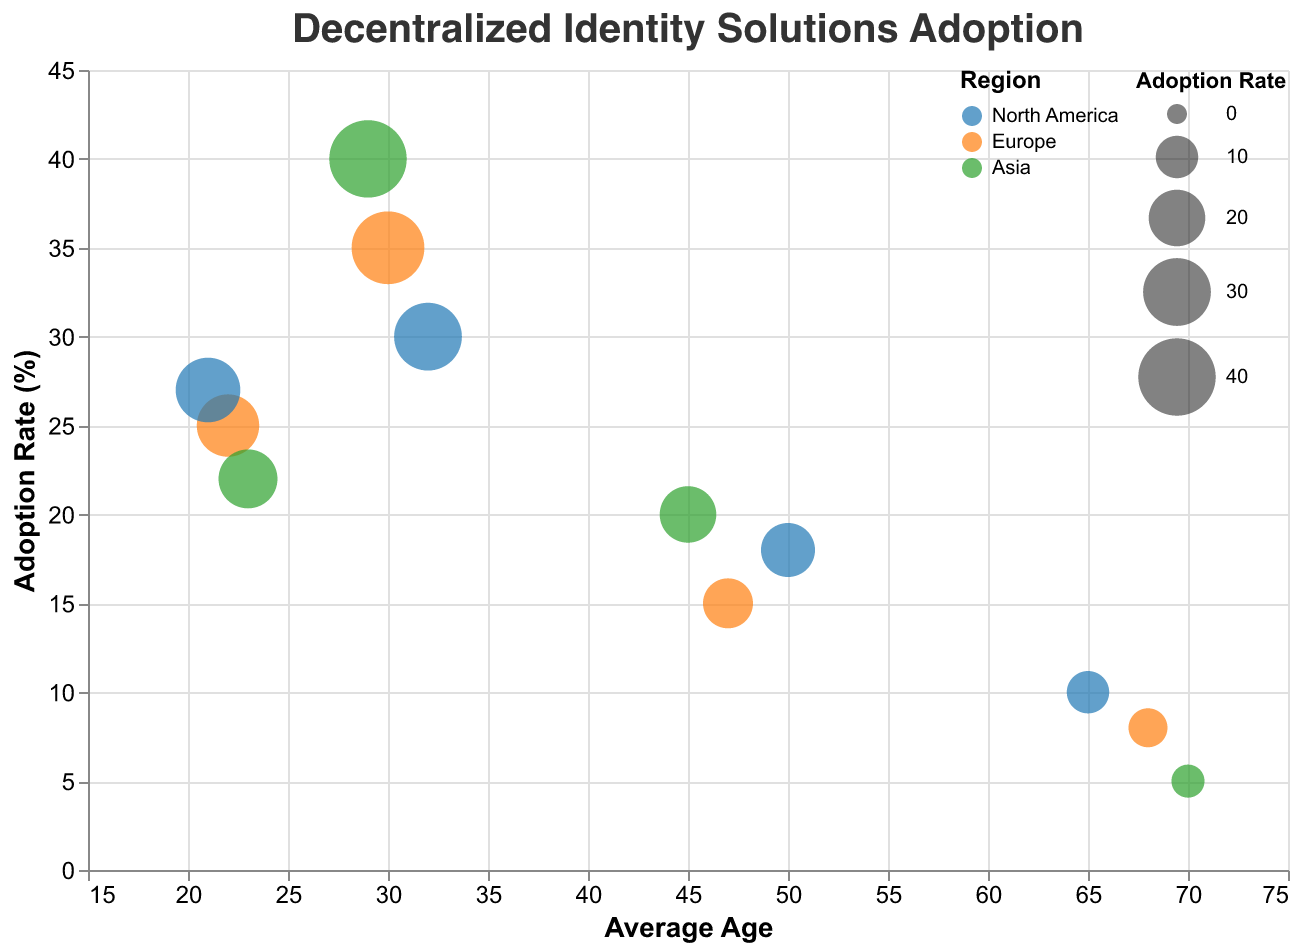What demographic group has the highest adoption rate in Asia? From the Bubble Chart, SolidChain representing Millennials in Asia has the highest adoption rate. The bubble size and position indicate an adoption rate of 40%.
Answer: Millennials What's the overall trend in adoption rate versus average age? Observing the Bubble Chart, as the average age increases, the adoption rate generally decreases. Younger groups (Millennials and Gen Z) have higher adoption rates compared to older groups (Gen X and Baby Boomers).
Answer: Decreases Which demographic group in North America has the lowest adoption rate? Looking at the Bubble Chart, CryptoID representing Baby Boomers in North America has the lowest adoption rate with a value of 10%.
Answer: Baby Boomers How does the adoption rate for Millennials compare across different regions? In North America, Millennials have an adoption rate of 30%. In Europe, they have 35%. In Asia, the adoption rate is 40%. The Bubble Chart shows that the adoption rate is highest in Asia, followed by Europe, and then North America.
Answer: Asia > Europe > North America Which group has the highest interest in blockchain in Europe and what is their adoption rate? The Bubble representing Gen Z in Europe (ChainSecure) indicates "Very High" interest in blockchain with an adoption rate of 25%.
Answer: Gen Z, 25% What’s the difference in adoption rates between Gen Z in North America and Europe? Gen Z in North America (ChainGuard) has an adoption rate of 27%, while in Europe (ChainSecure), it is 25%. The difference is 2%.
Answer: 2% Which region shows the lowest adoption rate for Baby Boomers and what's the value? The Bubble representing Baby Boomers in Asia (DigitalAnchor) showcases the lowest adoption rate with a value of 5%.
Answer: Asia, 5% What is the sum of adoption rates for all regions combined for Millennials? Summing up the adoption rates from the Bubble Chart: North America (30%), Europe (35%), Asia (40%). The total is 30 + 35 + 40 = 105%.
Answer: 105% What is the average adoption rate across all regions for Gen X? Summing the adoption rates from the Bubble Chart: Asia (20%), North America (18%), Europe (15%). The sum is 20 + 18 + 15 = 53. Dividing by 3, the average is 53/3 ≈ 17.67%.
Answer: 17.67% Does Gen Z have a higher interest in blockchain in Asia or North America and what is their adoption rate in the selected region? Gen Z's interest in blockchain in both Asia (VeriChain) and North America (ChainGuard) is "Very High". The adoption rate in North America is 27%, which is higher compared to 22% in Asia.
Answer: North America, 27% 